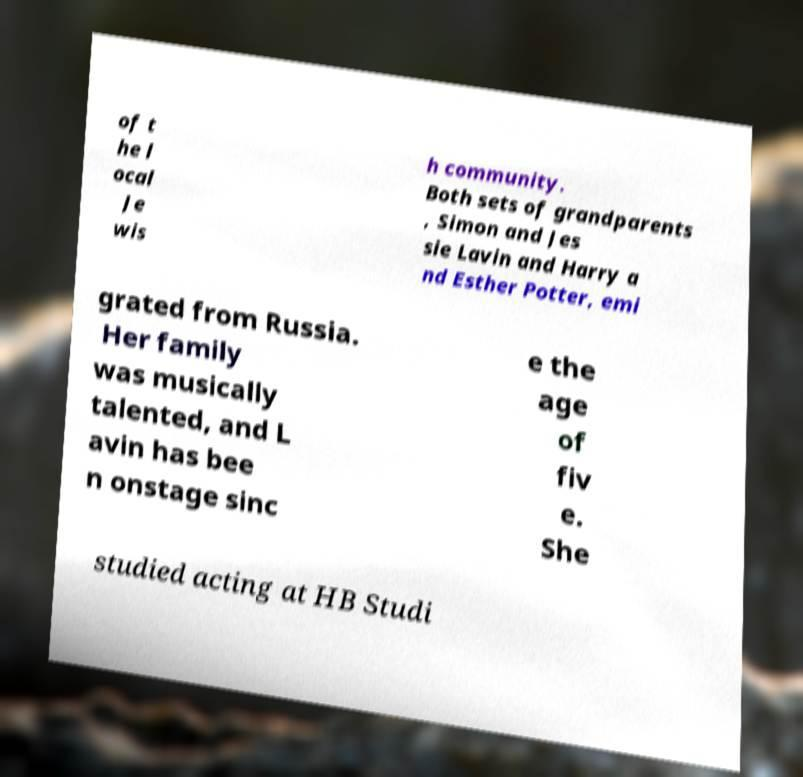For documentation purposes, I need the text within this image transcribed. Could you provide that? of t he l ocal Je wis h community. Both sets of grandparents , Simon and Jes sie Lavin and Harry a nd Esther Potter, emi grated from Russia. Her family was musically talented, and L avin has bee n onstage sinc e the age of fiv e. She studied acting at HB Studi 